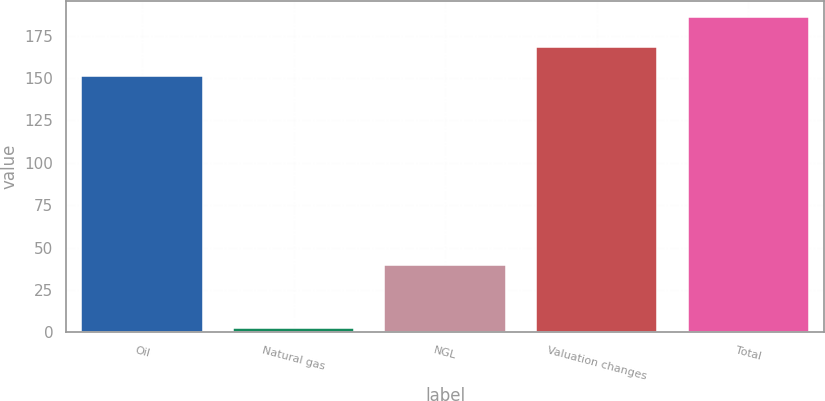<chart> <loc_0><loc_0><loc_500><loc_500><bar_chart><fcel>Oil<fcel>Natural gas<fcel>NGL<fcel>Valuation changes<fcel>Total<nl><fcel>151<fcel>2.45<fcel>40<fcel>168.56<fcel>186.12<nl></chart> 